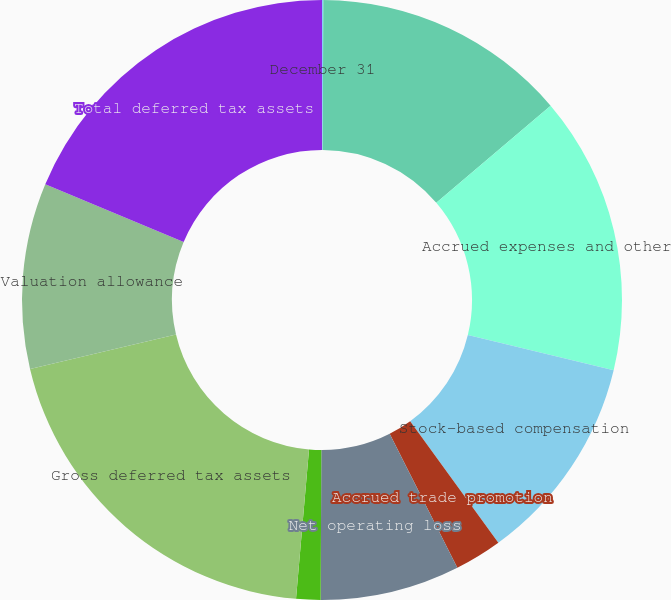Convert chart. <chart><loc_0><loc_0><loc_500><loc_500><pie_chart><fcel>December 31<fcel>Post-retirement benefit<fcel>Accrued expenses and other<fcel>Stock-based compensation<fcel>Accrued trade promotion<fcel>Net operating loss<fcel>Other<fcel>Gross deferred tax assets<fcel>Valuation allowance<fcel>Total deferred tax assets<nl><fcel>0.07%<fcel>13.72%<fcel>14.97%<fcel>11.24%<fcel>2.55%<fcel>7.52%<fcel>1.31%<fcel>19.93%<fcel>10.0%<fcel>18.69%<nl></chart> 